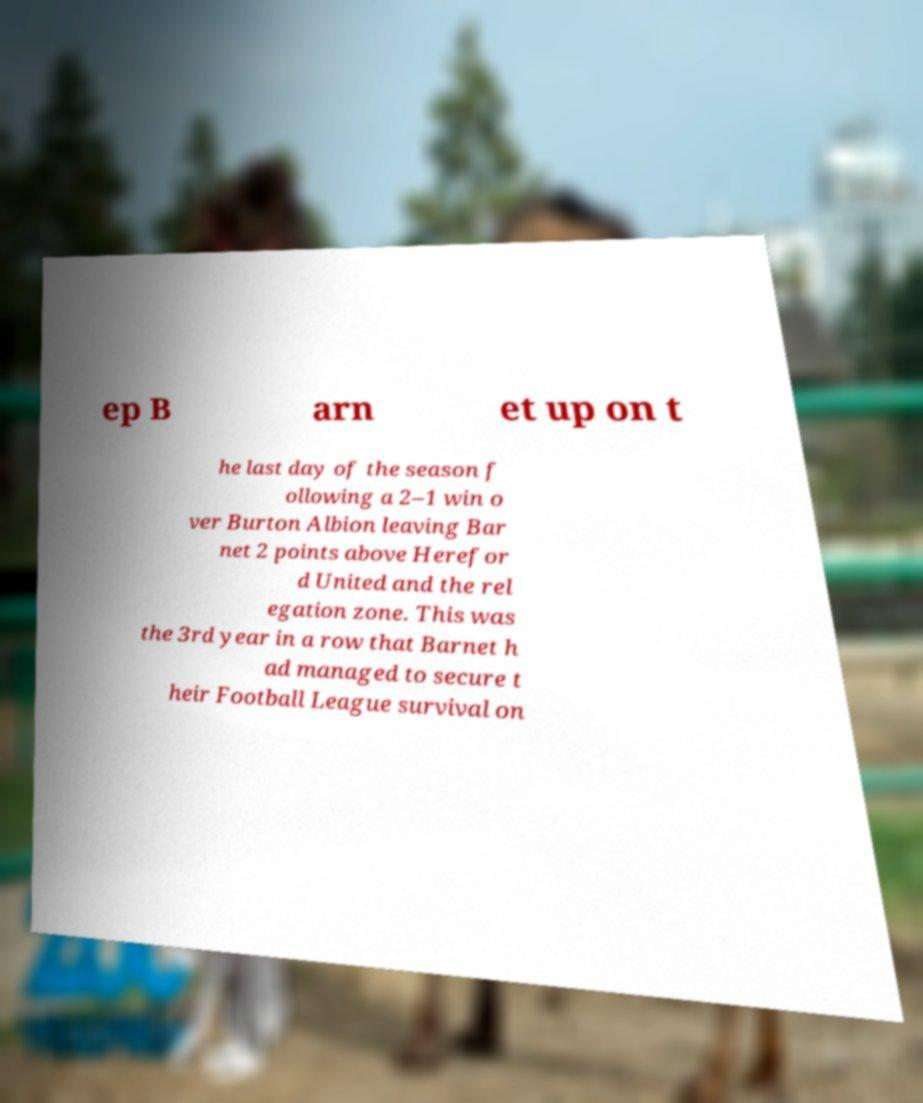What messages or text are displayed in this image? I need them in a readable, typed format. ep B arn et up on t he last day of the season f ollowing a 2–1 win o ver Burton Albion leaving Bar net 2 points above Herefor d United and the rel egation zone. This was the 3rd year in a row that Barnet h ad managed to secure t heir Football League survival on 